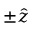<formula> <loc_0><loc_0><loc_500><loc_500>\pm \hat { z }</formula> 